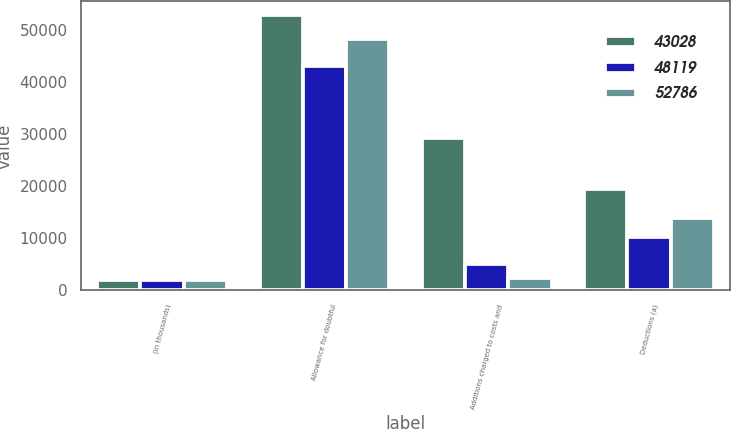Convert chart to OTSL. <chart><loc_0><loc_0><loc_500><loc_500><stacked_bar_chart><ecel><fcel>(in thousands)<fcel>Allowance for doubtful<fcel>Additions charged to costs and<fcel>Deductions (a)<nl><fcel>43028<fcel>2017<fcel>52786<fcel>29248<fcel>19490<nl><fcel>48119<fcel>2016<fcel>43028<fcel>5060<fcel>10151<nl><fcel>52786<fcel>2015<fcel>48119<fcel>2317<fcel>13888<nl></chart> 